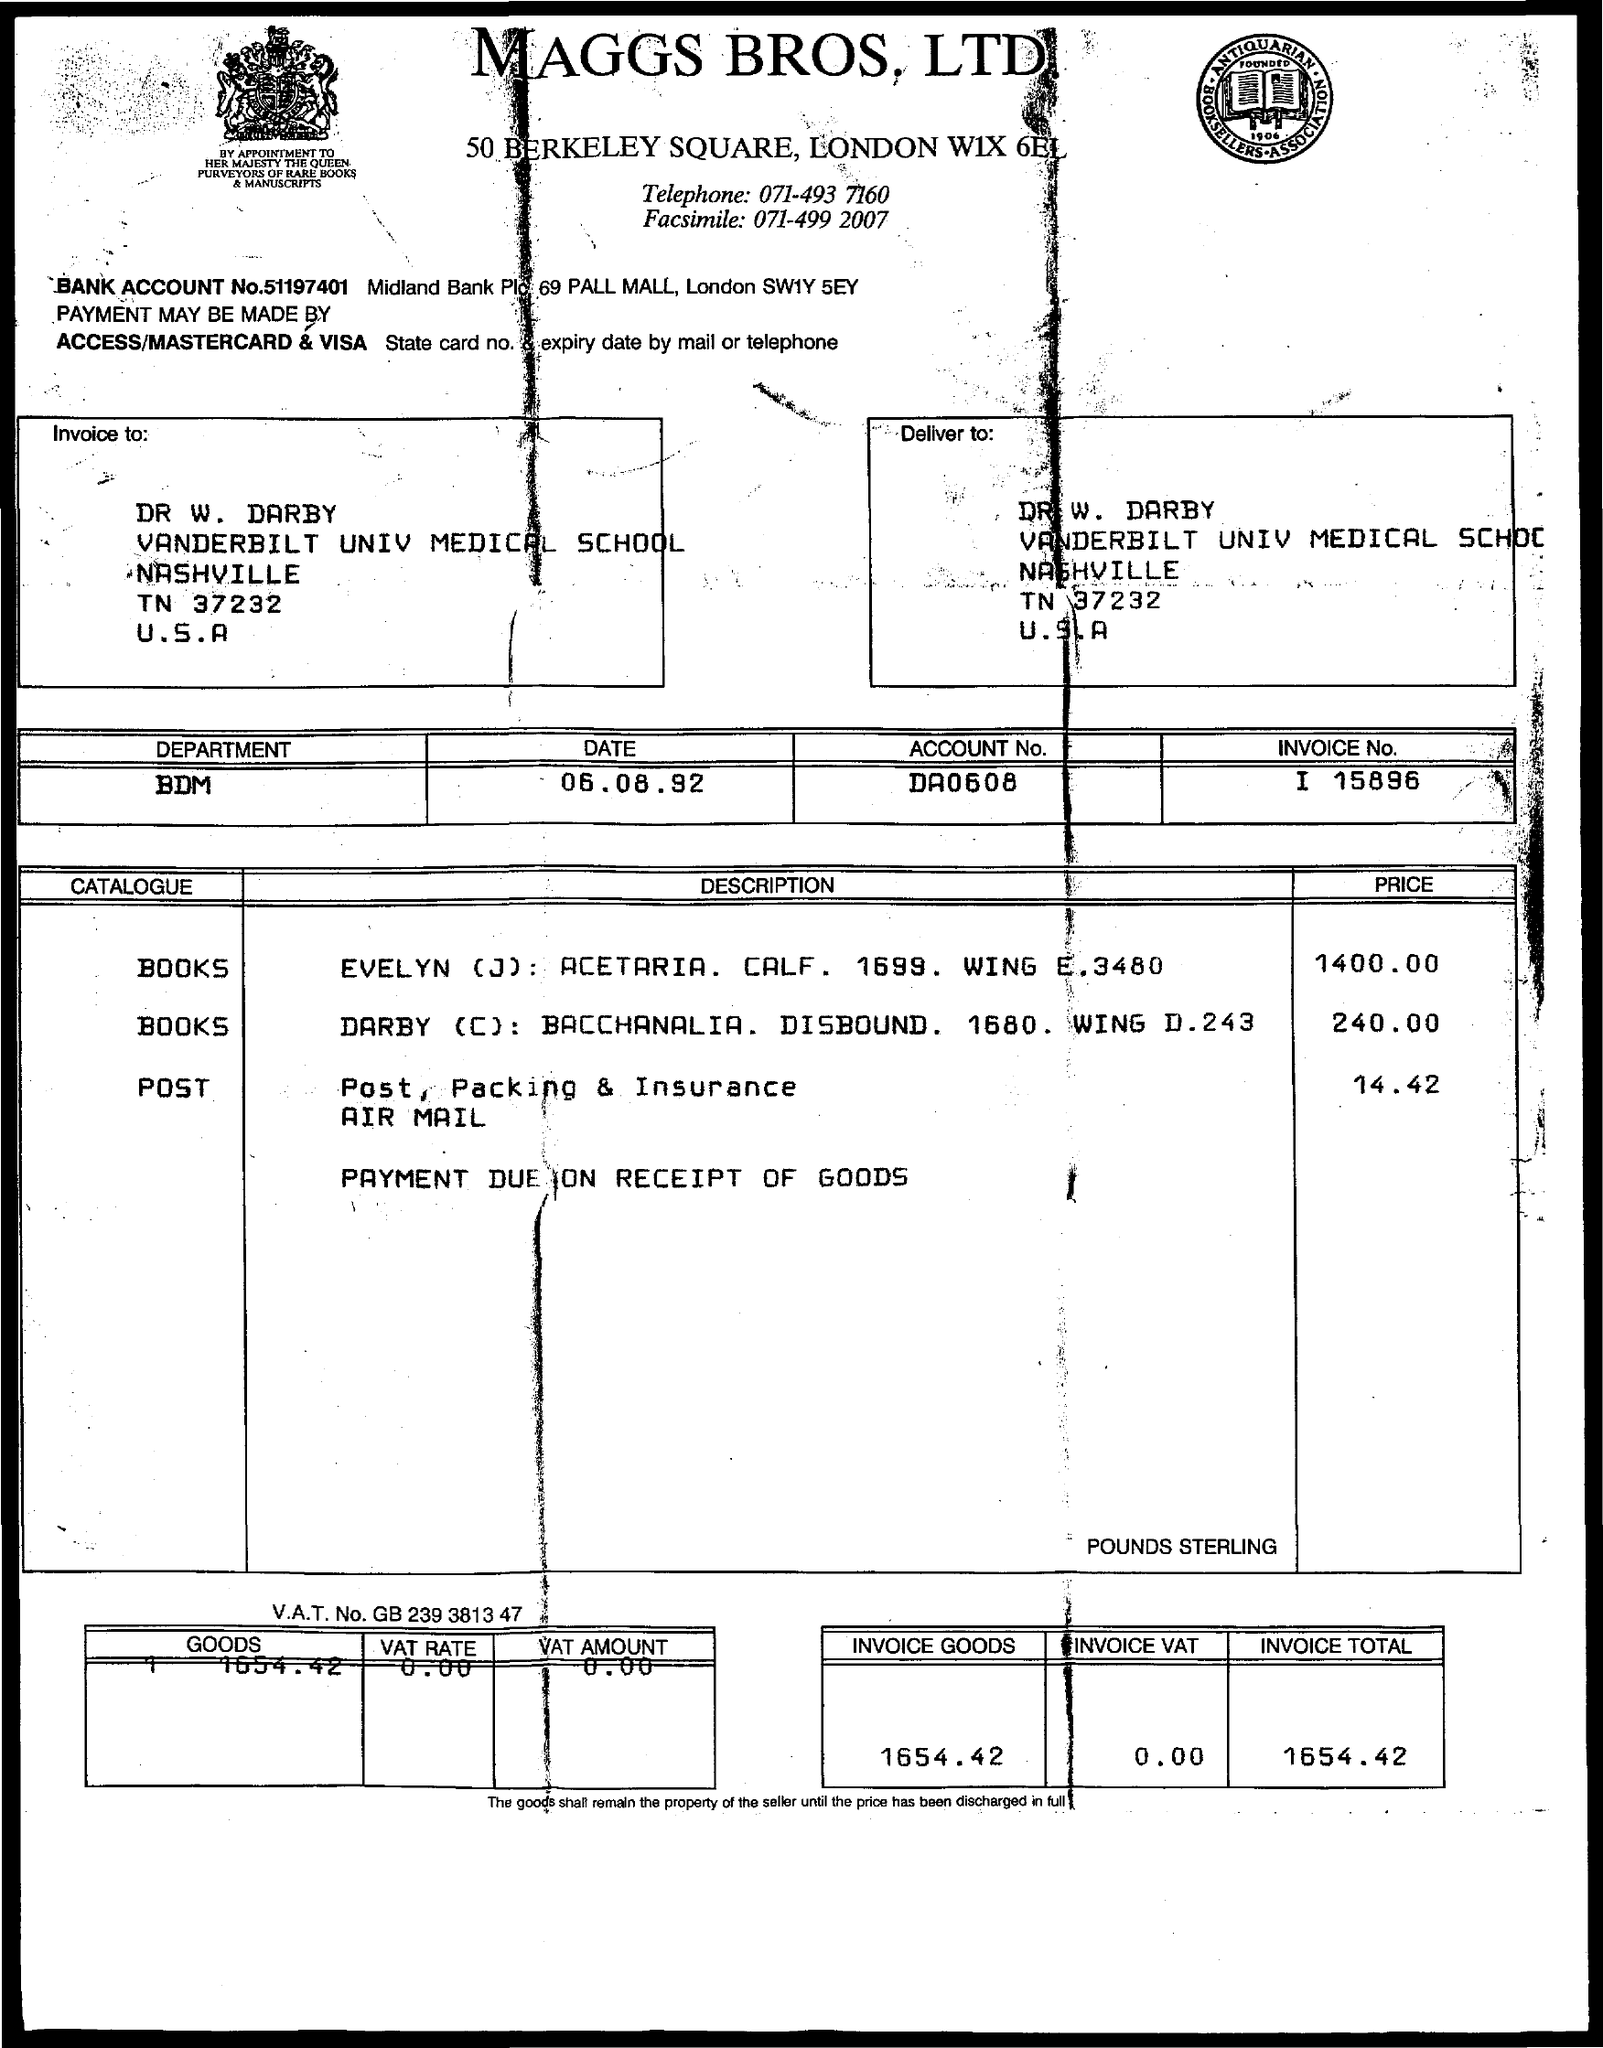What is the title of the document?
Give a very brief answer. Maggs bros, ltd. What is the Invoice No.?
Provide a succinct answer. I 15896. What is the Invoice Total?
Ensure brevity in your answer.  1654.42. What is the date mentioned in the document?
Provide a short and direct response. 06.08.92. What is the price of the post?
Offer a very short reply. 14.42. 